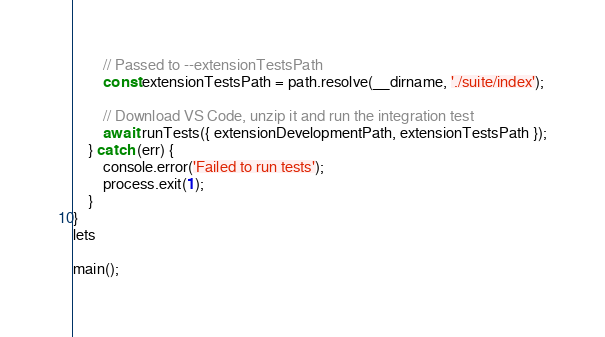Convert code to text. <code><loc_0><loc_0><loc_500><loc_500><_JavaScript_>		// Passed to --extensionTestsPath
		const extensionTestsPath = path.resolve(__dirname, './suite/index');

		// Download VS Code, unzip it and run the integration test
		await runTests({ extensionDevelopmentPath, extensionTestsPath });
	} catch (err) {
		console.error('Failed to run tests');
		process.exit(1);
	}
}
lets

main();
</code> 